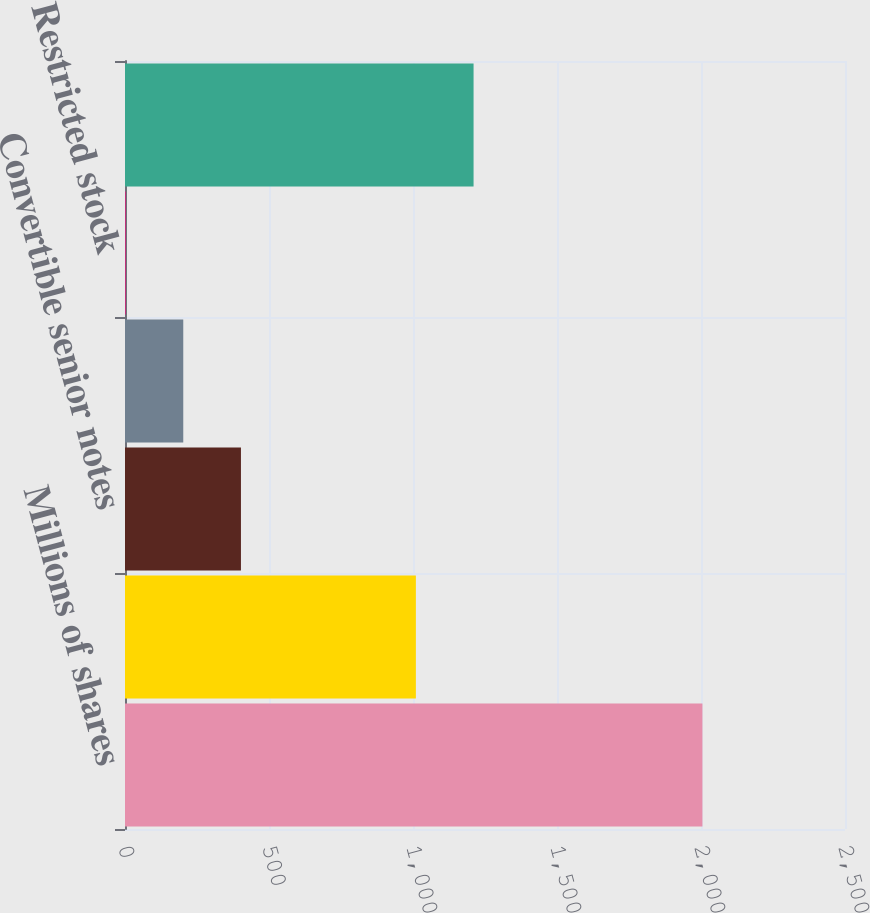Convert chart. <chart><loc_0><loc_0><loc_500><loc_500><bar_chart><fcel>Millions of shares<fcel>Basic weighted average common<fcel>Convertible senior notes<fcel>Stock options<fcel>Restricted stock<fcel>Diluted weighted average<nl><fcel>2005<fcel>1010<fcel>402.6<fcel>202.3<fcel>2<fcel>1210.3<nl></chart> 